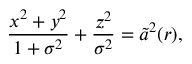Convert formula to latex. <formula><loc_0><loc_0><loc_500><loc_500>\frac { x ^ { 2 } + y ^ { 2 } } { 1 + \sigma ^ { 2 } } + \frac { z ^ { 2 } } { \sigma ^ { 2 } } = \widetilde { a } ^ { 2 } ( r ) ,</formula> 